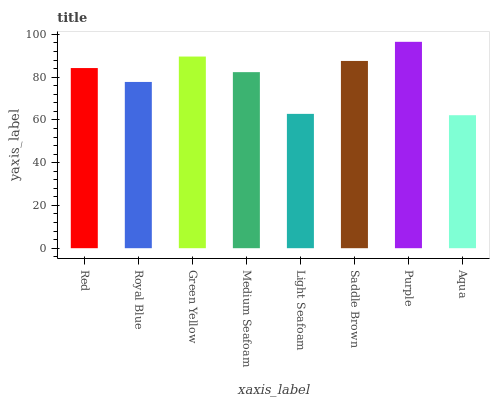Is Aqua the minimum?
Answer yes or no. Yes. Is Purple the maximum?
Answer yes or no. Yes. Is Royal Blue the minimum?
Answer yes or no. No. Is Royal Blue the maximum?
Answer yes or no. No. Is Red greater than Royal Blue?
Answer yes or no. Yes. Is Royal Blue less than Red?
Answer yes or no. Yes. Is Royal Blue greater than Red?
Answer yes or no. No. Is Red less than Royal Blue?
Answer yes or no. No. Is Red the high median?
Answer yes or no. Yes. Is Medium Seafoam the low median?
Answer yes or no. Yes. Is Light Seafoam the high median?
Answer yes or no. No. Is Green Yellow the low median?
Answer yes or no. No. 